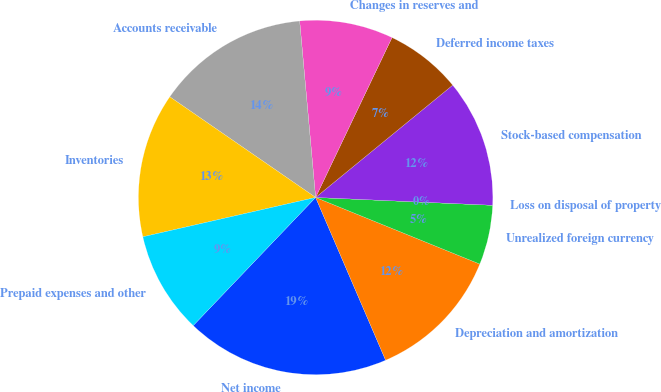<chart> <loc_0><loc_0><loc_500><loc_500><pie_chart><fcel>Net income<fcel>Depreciation and amortization<fcel>Unrealized foreign currency<fcel>Loss on disposal of property<fcel>Stock-based compensation<fcel>Deferred income taxes<fcel>Changes in reserves and<fcel>Accounts receivable<fcel>Inventories<fcel>Prepaid expenses and other<nl><fcel>18.6%<fcel>12.4%<fcel>5.43%<fcel>0.0%<fcel>11.63%<fcel>6.98%<fcel>8.53%<fcel>13.95%<fcel>13.18%<fcel>9.3%<nl></chart> 